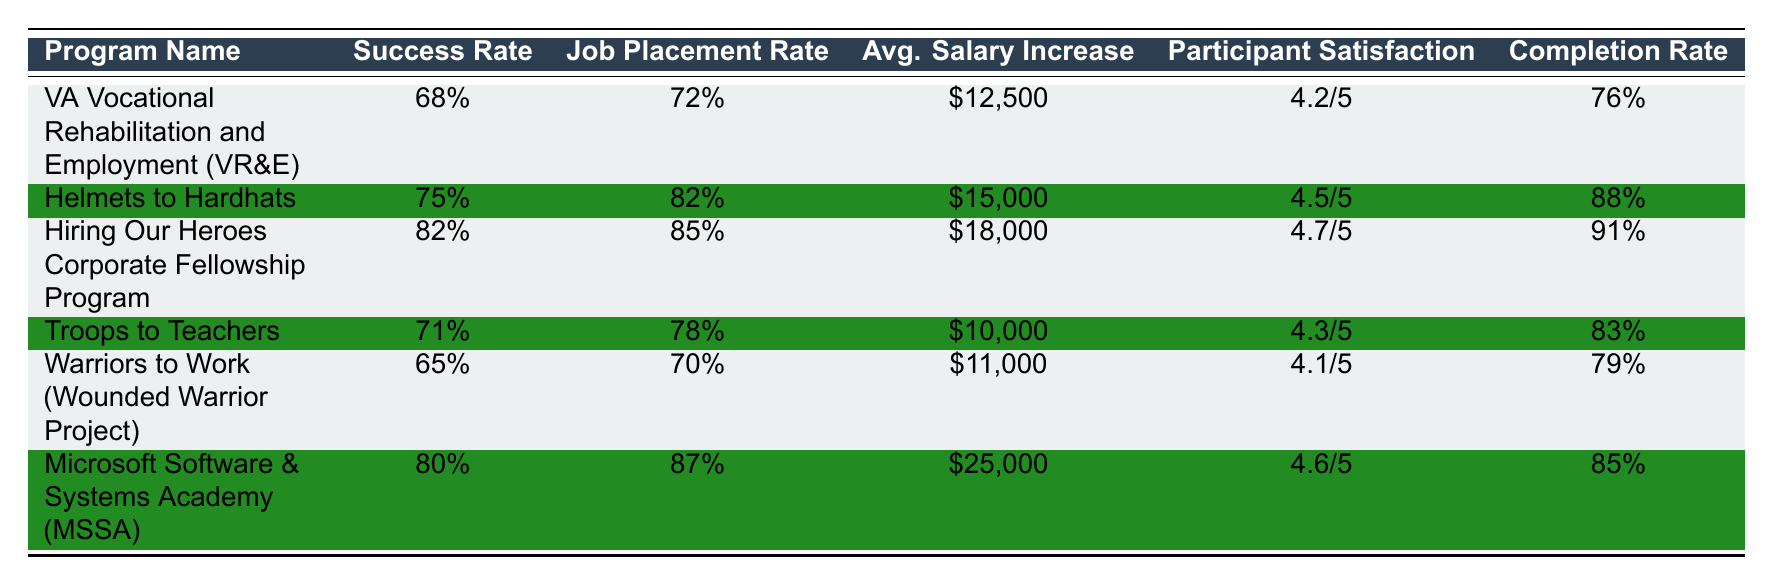What is the success rate of the Hiring Our Heroes Corporate Fellowship Program? The success rate for this program is listed directly in the table under the "Success Rate" column. It shows "82%".
Answer: 82% Which program has the highest participant satisfaction? By examining the "Participant Satisfaction" column, the program with the highest rating is "Hiring Our Heroes Corporate Fellowship Program" with a score of "4.7/5".
Answer: Hiring Our Heroes Corporate Fellowship Program What is the average salary increase for the Microsoft Software & Systems Academy? The table states the average salary increase for this program as "$25,000", which can be found under the respective column for that program.
Answer: $25,000 True or False: The Warriors to Work program has a job placement rate higher than 75%. The job placement rate for the Warriors to Work is "70%", which is lower than 75%. Therefore, the statement is false.
Answer: False What is the difference in success rates between the Helmets to Hardhats program and the Warriors to Work program? The success rate for Helmets to Hardhats is "75%" and for Warriors to Work is "65%". The difference is calculated as 75% - 65% = 10%.
Answer: 10% Which program has both a job placement rate and completion rate over 80%? The programs with a job placement rate over 80% include "Hiring Our Heroes Corporate Fellowship Program" (85%) and "Microsoft Software & Systems Academy" (87%). They also both have completion rates above 80%, 91% and 85% respectively.
Answer: Hiring Our Heroes Corporate Fellowship Program and Microsoft Software & Systems Academy How many programs have a success rate below 70%? By checking the "Success Rate" column, the programs below 70% are "VA Vocational Rehabilitation and Employment" at 68% and "Warriors to Work" at 65%. This totals two programs.
Answer: 2 What is the average participant satisfaction across all programs? To calculate the average, convert the ratings from five programs to numerical values: (4.2 + 4.5 + 4.7 + 4.3 + 4.1 + 4.6)/6 = 4.45.Therefore, the average participant satisfaction is 4.45.
Answer: 4.45 Which program had the lowest completion rate? By looking at the "Completion Rate" column, "VA Vocational Rehabilitation and Employment" has the lowest rate at "76%".
Answer: VA Vocational Rehabilitation and Employment 